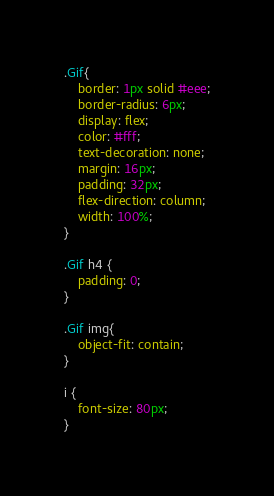Convert code to text. <code><loc_0><loc_0><loc_500><loc_500><_CSS_>.Gif{
    border: 1px solid #eee;
    border-radius: 6px;
    display: flex;
    color: #fff;
    text-decoration: none;
    margin: 16px;
    padding: 32px;
    flex-direction: column;
    width: 100%;
}

.Gif h4 {
    padding: 0;
}

.Gif img{
    object-fit: contain;
}

i {
    font-size: 80px;
}</code> 